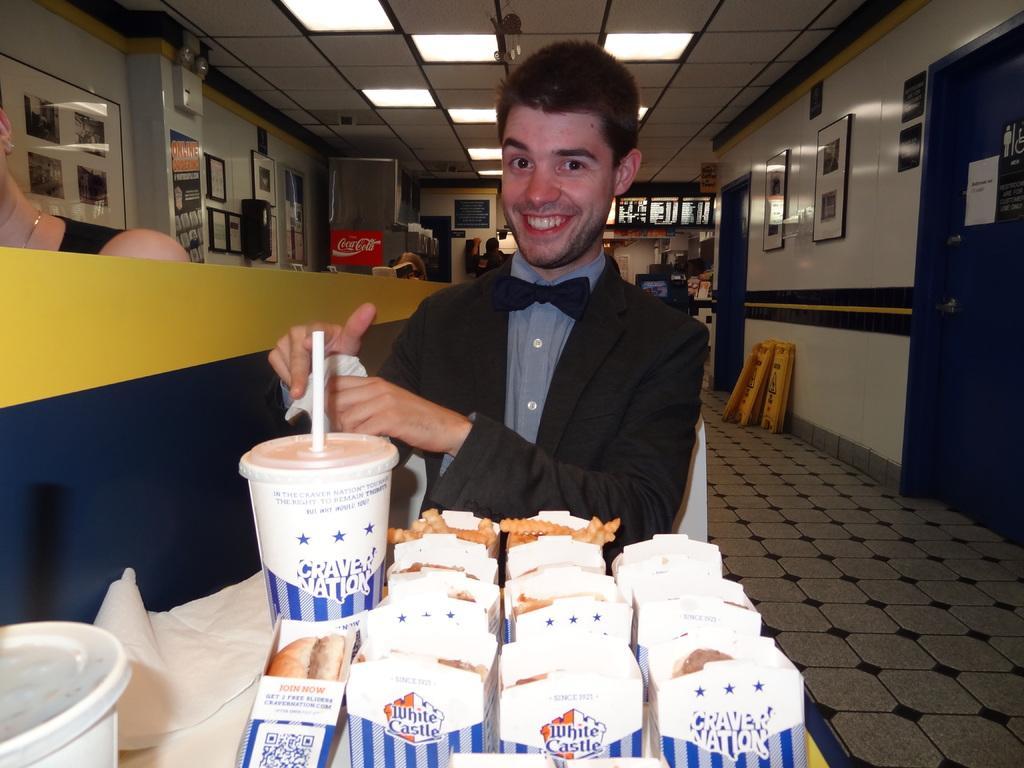In one or two sentences, can you explain what this image depicts? In this image I can see four people. The person who is sitting in the center of the image is having a table in front of him with so many food wrappers and beverages. I can see a door on the right side of the image I can see wall paintings. I can see some other objects behind the person and on the left side of the image I can see wall posters with some text and other objects. At the top of the image I can see a false ceiling.  